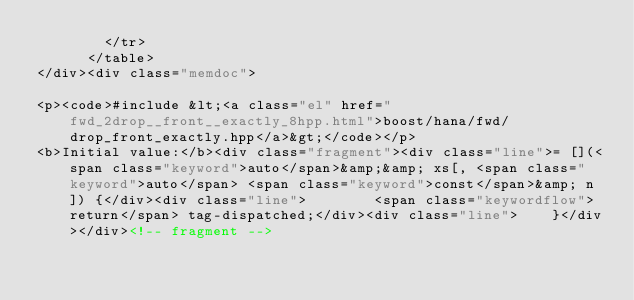<code> <loc_0><loc_0><loc_500><loc_500><_HTML_>        </tr>
      </table>
</div><div class="memdoc">

<p><code>#include &lt;<a class="el" href="fwd_2drop__front__exactly_8hpp.html">boost/hana/fwd/drop_front_exactly.hpp</a>&gt;</code></p>
<b>Initial value:</b><div class="fragment"><div class="line">= [](<span class="keyword">auto</span>&amp;&amp; xs[, <span class="keyword">auto</span> <span class="keyword">const</span>&amp; n]) {</div><div class="line">        <span class="keywordflow">return</span> tag-dispatched;</div><div class="line">    }</div></div><!-- fragment --></code> 